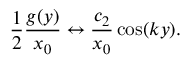<formula> <loc_0><loc_0><loc_500><loc_500>\frac { 1 } { 2 } \frac { g ( y ) } { x _ { 0 } } \leftrightarrow \frac { c _ { 2 } } { x _ { 0 } } \cos ( k y ) .</formula> 